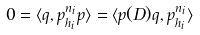Convert formula to latex. <formula><loc_0><loc_0><loc_500><loc_500>0 = \langle q , p _ { h _ { i } } ^ { n _ { i } } p \rangle = \langle p ( D ) q , p _ { h _ { i } } ^ { n _ { i } } \rangle</formula> 